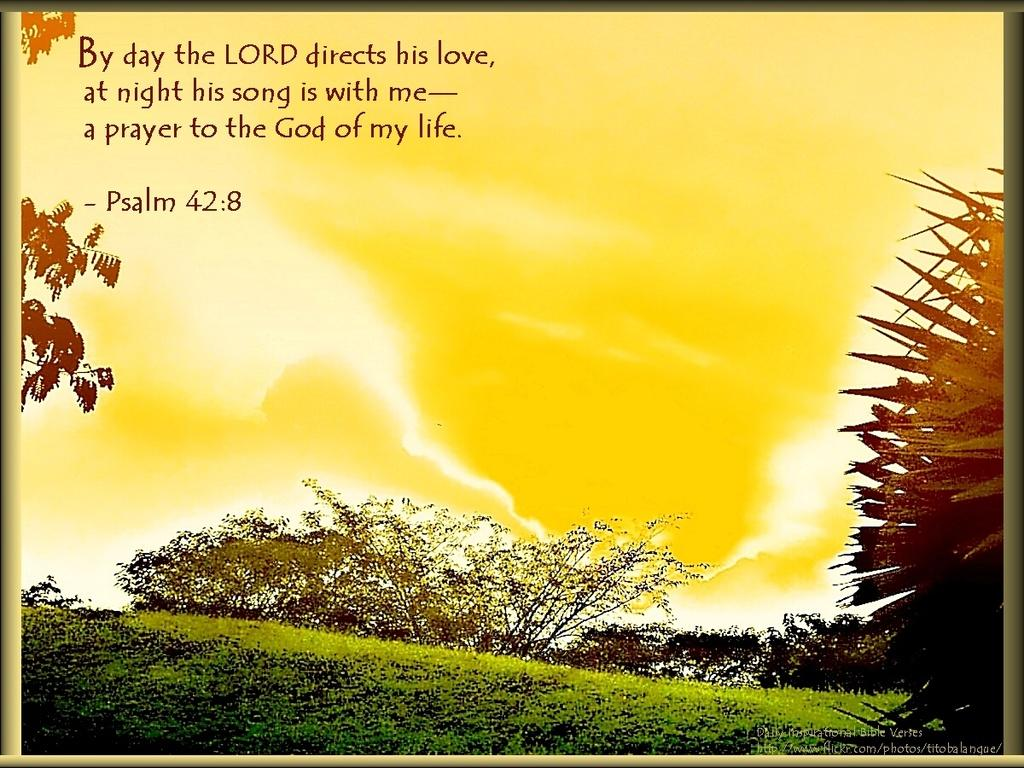What is the main object in the picture? There is a card in the picture. What can be seen in the background of the card? The card has a grass background, and there are trees and the sky visible in the background. What is written on the card? There is a quotation on the card. Is there any additional design element on the card? Yes, there is a watermark on the image. Can you see the mouth of the person who created the card in the image? There is no person or mouth visible in the image; it only features a card with a grass background, trees, sky, a quotation, and a watermark. 